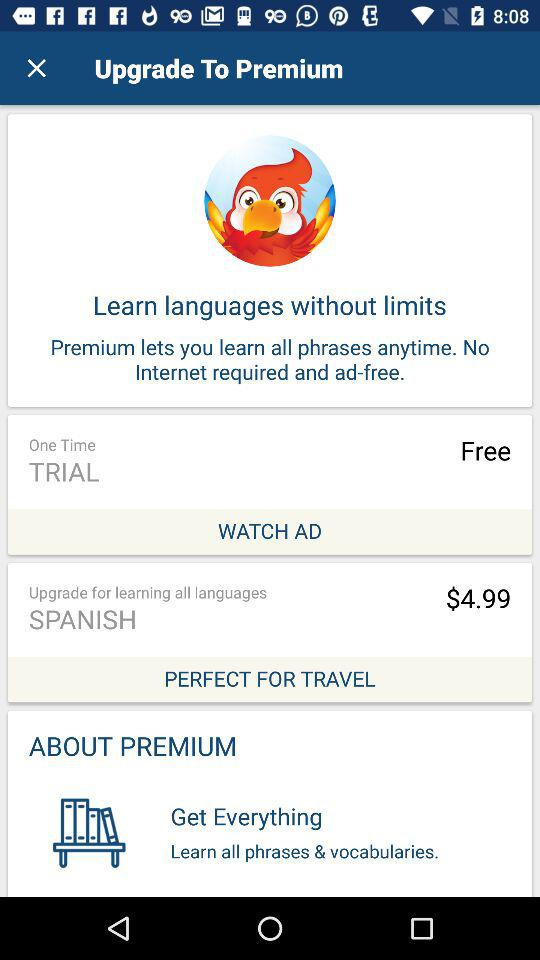How many free trails are available? The free trial is available only once. 